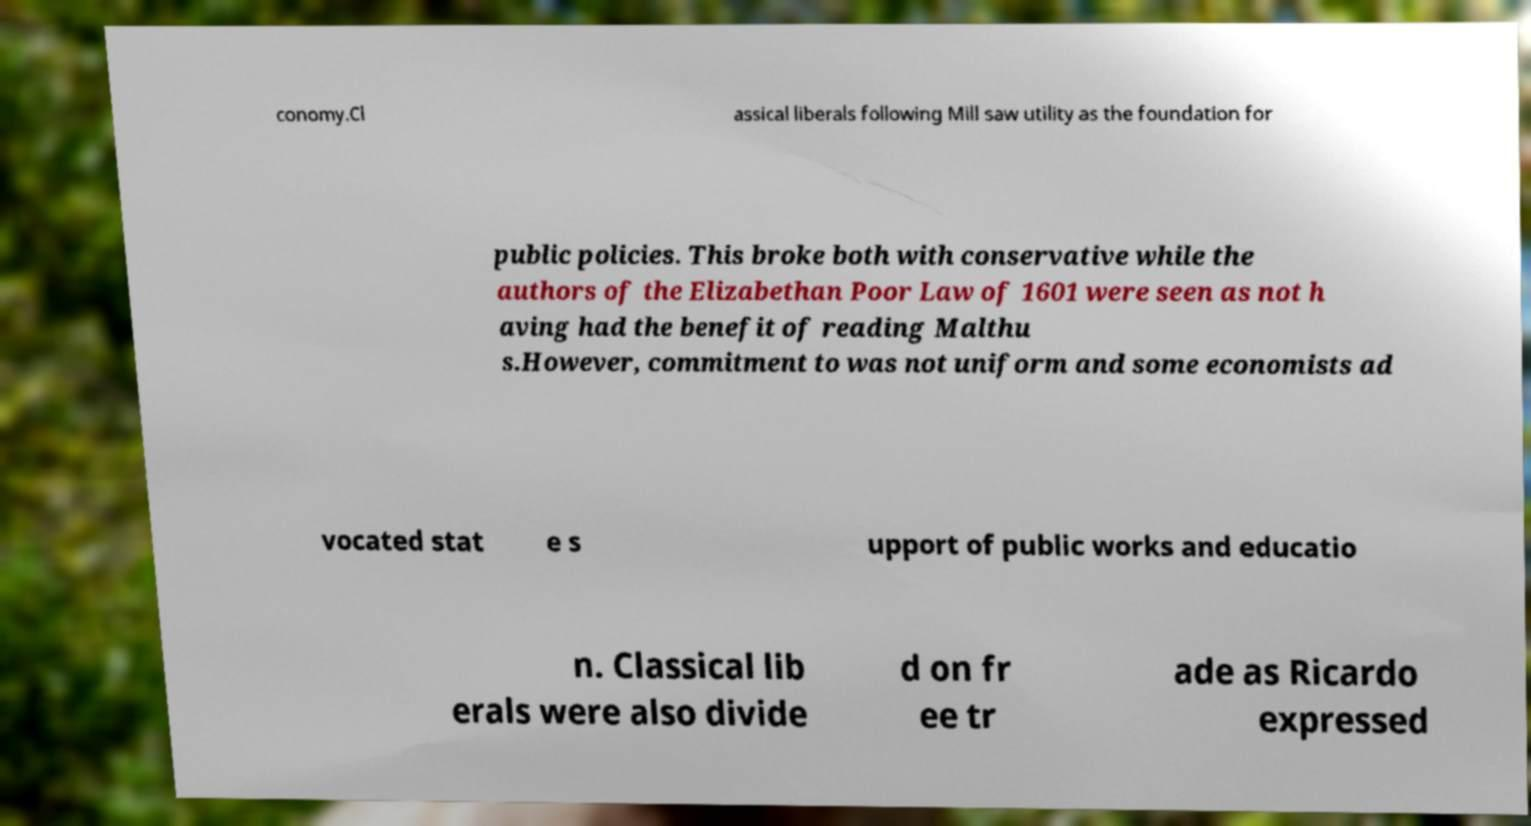Can you accurately transcribe the text from the provided image for me? conomy.Cl assical liberals following Mill saw utility as the foundation for public policies. This broke both with conservative while the authors of the Elizabethan Poor Law of 1601 were seen as not h aving had the benefit of reading Malthu s.However, commitment to was not uniform and some economists ad vocated stat e s upport of public works and educatio n. Classical lib erals were also divide d on fr ee tr ade as Ricardo expressed 